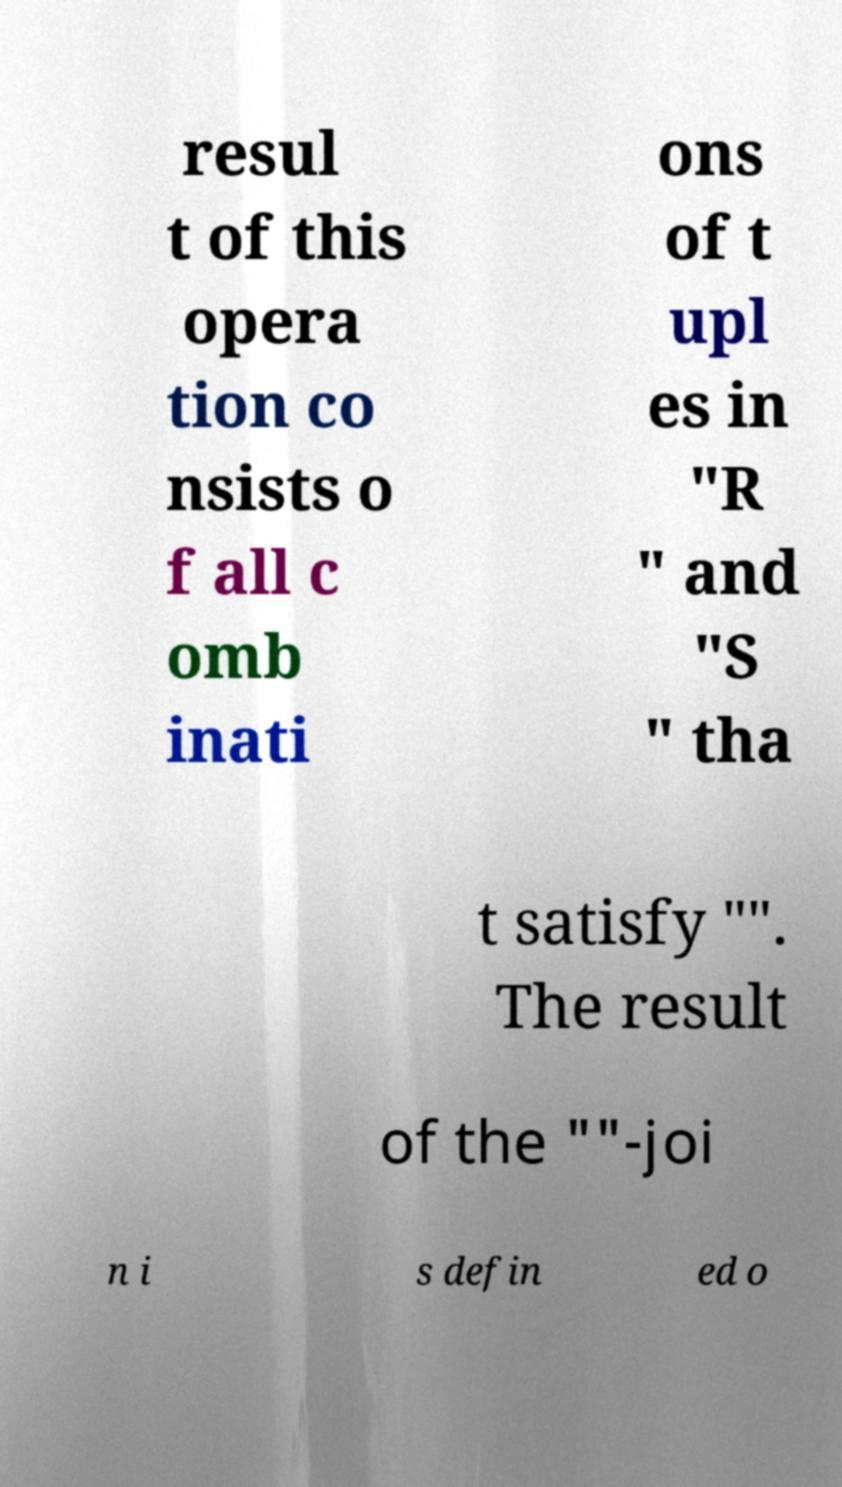Please read and relay the text visible in this image. What does it say? resul t of this opera tion co nsists o f all c omb inati ons of t upl es in "R " and "S " tha t satisfy "". The result of the ""-joi n i s defin ed o 